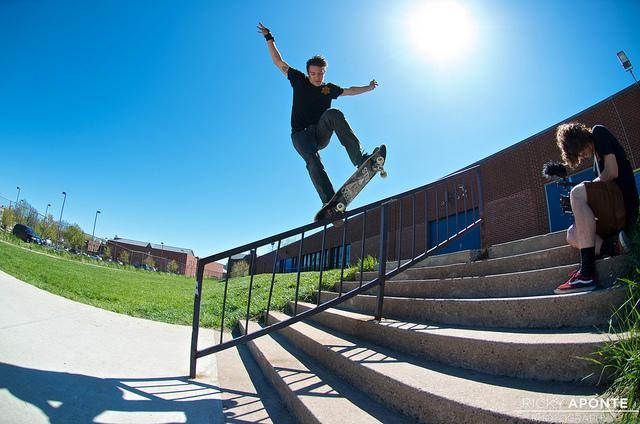Why is there a bright circle? Please explain your reasoning. sun light. The sun is shinning so bright in the sky. 